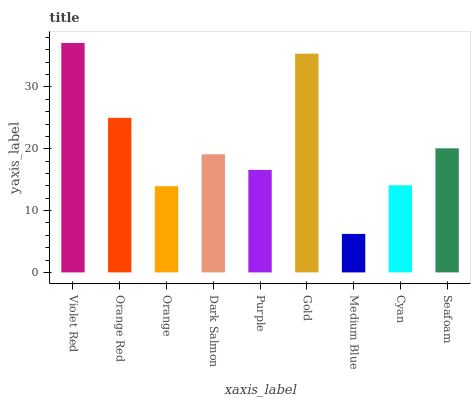Is Medium Blue the minimum?
Answer yes or no. Yes. Is Violet Red the maximum?
Answer yes or no. Yes. Is Orange Red the minimum?
Answer yes or no. No. Is Orange Red the maximum?
Answer yes or no. No. Is Violet Red greater than Orange Red?
Answer yes or no. Yes. Is Orange Red less than Violet Red?
Answer yes or no. Yes. Is Orange Red greater than Violet Red?
Answer yes or no. No. Is Violet Red less than Orange Red?
Answer yes or no. No. Is Dark Salmon the high median?
Answer yes or no. Yes. Is Dark Salmon the low median?
Answer yes or no. Yes. Is Cyan the high median?
Answer yes or no. No. Is Seafoam the low median?
Answer yes or no. No. 